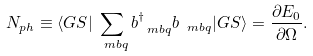<formula> <loc_0><loc_0><loc_500><loc_500>N _ { p h } \equiv \langle G S | \sum _ { \ m b { q } } b _ { \ m b { q } } ^ { \dagger } b _ { \ m b { q } } | G S \rangle = \frac { \partial E _ { 0 } } { \partial \Omega } .</formula> 